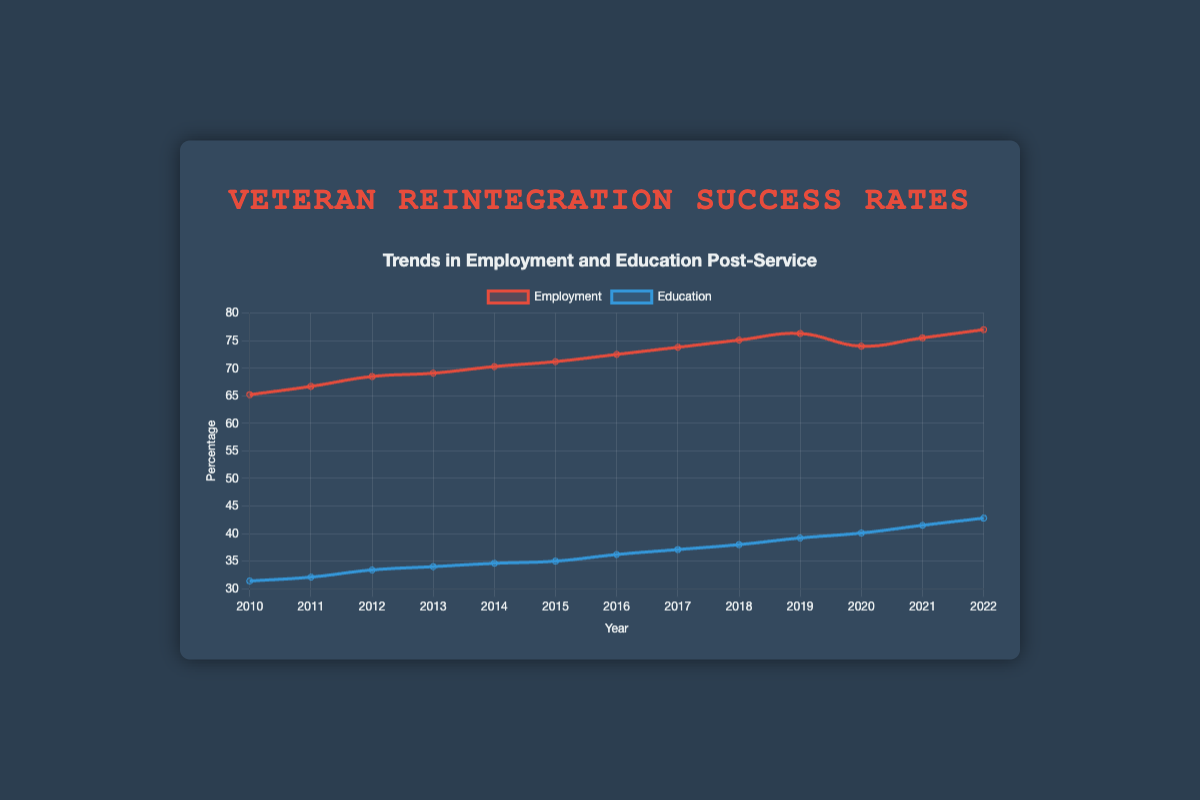What is the trend in employment rates from 2010 to 2022? The employment rate generally increased from 65.2% in 2010 to 77.0% in 2022, with a slight dip in 2020 due to the COVID-19 pandemic.
Answer: Increasing trend, except 2020 How does the education rate in 2018 compare to that in 2010? The education rate increased from 31.4% in 2010 to 38.0% in 2018. By subtracting 31.4 from 38.0, the difference is 6.6%.
Answer: 6.6% higher What is the average employment rate from 2010 to 2022? Sum the employment rates for each year (65.2 + 66.7 + 68.5 + 69.1 + 70.3 + 71.2 + 72.5 + 73.8 + 75.1 + 76.3 + 74.0 + 75.5 + 77.0) to get 935.2, then divide by 13 to get the average, which is approximately 71.9%.
Answer: 71.9% When did the education rate reach 40%? The education rate reached 40.1% in 2020. By looking at the education rates list, we can determine the year it first crossed the 40% mark.
Answer: 2020 Which year had the most significant increase in employment rate from the previous year? The increase from 2019 to 2020 is -2.3%, while from 2021 to 2022, the increase is 1.5%. Comparing year-over-year increases, 2018 to 2019 shows the highest increase of 1.2%.
Answer: 2018 to 2019 In which year did both employment and education rates increase compared to the previous year? Checking each year, both rates show an increase from 2020 to 2021. Employment went from 74.0% to 75.5%, and education from 40.1% to 41.5%.
Answer: 2021 Determine the median education rate from 2010 to 2022. List the education rates in ascending order: [31.4, 32.1, 33.4, 34.0, 34.6, 35.0, 36.2, 37.1, 38.0, 39.2, 40.1, 41.5, 42.8]. The median is the middle value in this ordered list, so the median is 36.2%.
Answer: 36.2% How did the employment rate change during the COVID-19 pandemic? The employment rate decreased from 76.3% in 2019 to 74.0% in 2020, a decrease of 2.3%.
Answer: Decreased by 2.3% What was the education rate in the year when the 'Expansion of Post-9/11 GI Bill benefits' occurred? The 'Expansion of Post-9/11 GI Bill benefits' took place in 2011, and the education rate for that year is 32.1%.
Answer: 32.1% Is there any year where the employment rate declined compared to the previous year? Yes, the employment rate declined from 76.3% in 2019 to 74.0% in 2020. This is a decrease due to the COVID-19 pandemic.
Answer: 2020 